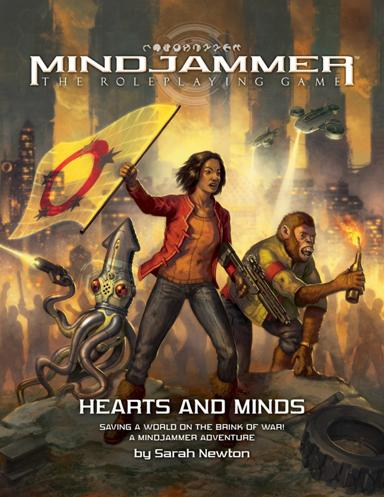What is the title of the adventure in the image and who is the author? The adventure shown in the image is titled 'Mindjammer', authored by Sarah Newton. This role-playing game, depicted with intense and captivating artwork, invites players into expansive space exploration and intense societal conflicts. 